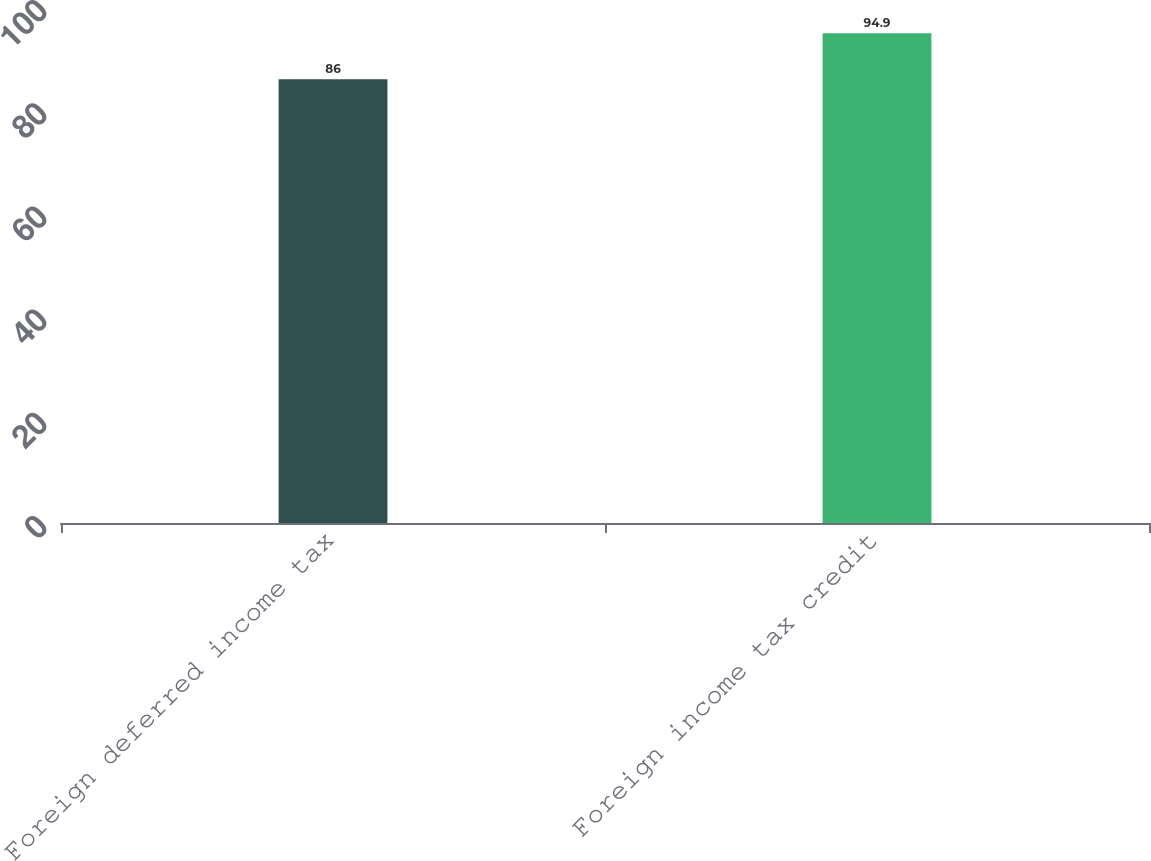Convert chart to OTSL. <chart><loc_0><loc_0><loc_500><loc_500><bar_chart><fcel>Foreign deferred income tax<fcel>Foreign income tax credit<nl><fcel>86<fcel>94.9<nl></chart> 